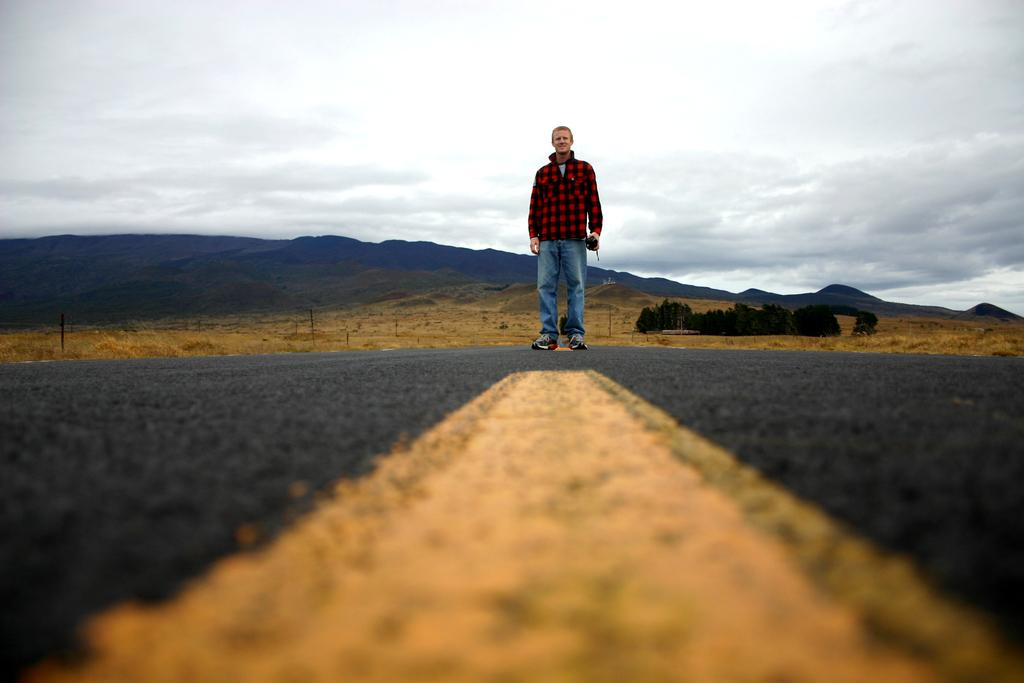What is the main subject of the image? There is a man in the middle of the image. What is the man holding in the image? The man is holding an object. What can be seen in the background of the image? There are trees, hills, and clouds in the background of the image. What type of liquid can be seen flowing through the patch in the image? There is no liquid or patch present in the image. 